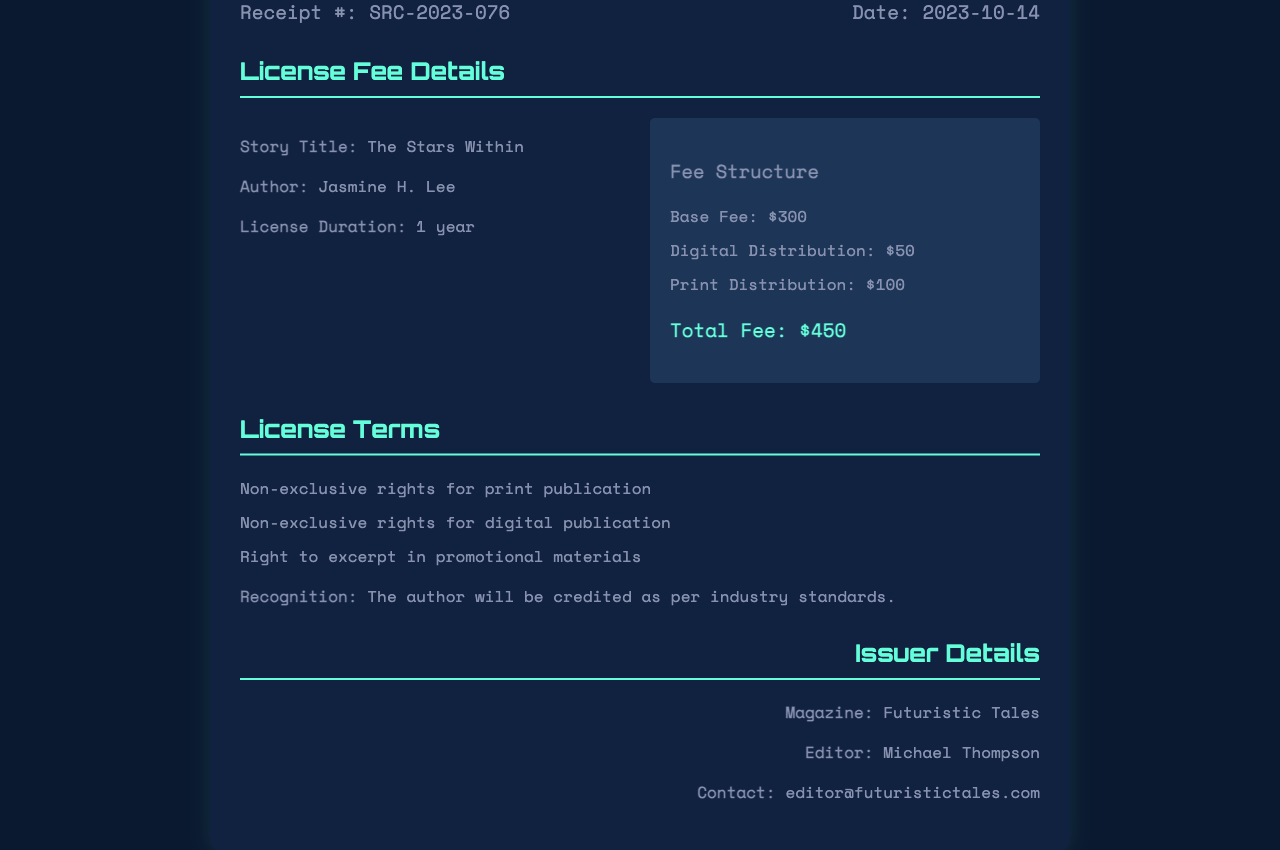What is the story title? The story title is explicitly listed in the receipt and is "The Stars Within."
Answer: The Stars Within Who is the author? The author's name is provided in the receipt, which is "Jasmine H. Lee."
Answer: Jasmine H. Lee What is the license duration? The duration for which the license is granted is specified in the document as "1 year."
Answer: 1 year What is the total fee? The total fee is mentioned in the receipt as the sum of various fees, which is "$450."
Answer: $450 What are the rights granted for this license? The license grants multiple rights, which include rights for print and digital publication, as stated in the document.
Answer: Non-exclusive rights for print and digital publication What is the base fee? The base fee is clearly stated in the fee structure as "$300."
Answer: $300 Who will be credited for the story? The document mentions that the author will be credited "as per industry standards."
Answer: As per industry standards What is the issue date of the receipt? The date on the receipt is specified as "2023-10-14."
Answer: 2023-10-14 Who is the editor of the magazine? The editor's name is mentioned in the document, which is "Michael Thompson."
Answer: Michael Thompson 